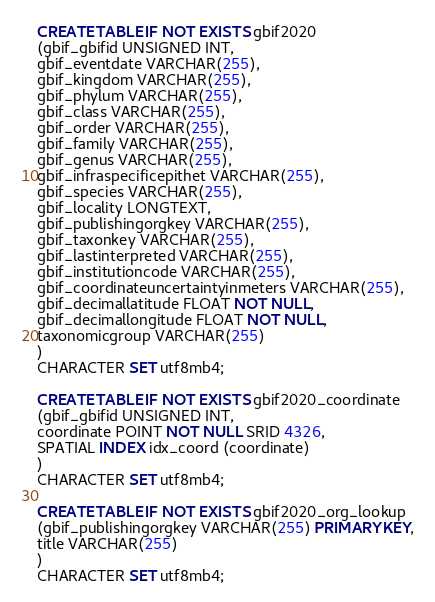Convert code to text. <code><loc_0><loc_0><loc_500><loc_500><_SQL_>CREATE TABLE IF NOT EXISTS gbif2020
(gbif_gbifid UNSIGNED INT,
gbif_eventdate VARCHAR(255),
gbif_kingdom VARCHAR(255),
gbif_phylum VARCHAR(255),
gbif_class VARCHAR(255),
gbif_order VARCHAR(255),
gbif_family VARCHAR(255),
gbif_genus VARCHAR(255),
gbif_infraspecificepithet VARCHAR(255),
gbif_species VARCHAR(255),
gbif_locality LONGTEXT,
gbif_publishingorgkey VARCHAR(255),
gbif_taxonkey VARCHAR(255),
gbif_lastinterpreted VARCHAR(255),
gbif_institutioncode VARCHAR(255),
gbif_coordinateuncertaintyinmeters VARCHAR(255),
gbif_decimallatitude FLOAT NOT NULL,
gbif_decimallongitude FLOAT NOT NULL,
taxonomicgroup VARCHAR(255)
)
CHARACTER SET utf8mb4;

CREATE TABLE IF NOT EXISTS gbif2020_coordinate
(gbif_gbifid UNSIGNED INT,
coordinate POINT NOT NULL SRID 4326,
SPATIAL INDEX idx_coord (coordinate)
)
CHARACTER SET utf8mb4;

CREATE TABLE IF NOT EXISTS gbif2020_org_lookup
(gbif_publishingorgkey VARCHAR(255) PRIMARY KEY,
title VARCHAR(255)
)
CHARACTER SET utf8mb4;
</code> 